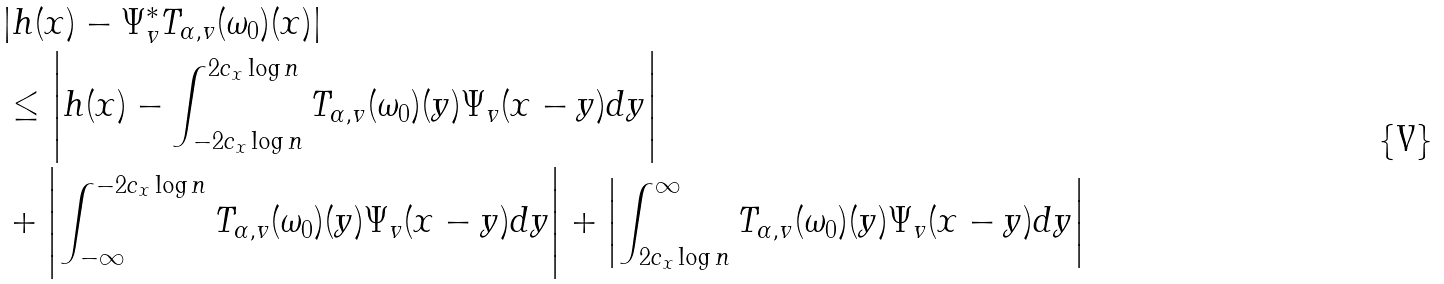<formula> <loc_0><loc_0><loc_500><loc_500>& | h ( x ) - \Psi _ { v } ^ { * } T _ { \alpha , v } ( \omega _ { 0 } ) ( x ) | \\ & \leq \left | h ( x ) - \int _ { - 2 c _ { x } \log n } ^ { 2 c _ { x } \log n } T _ { \alpha , v } ( \omega _ { 0 } ) ( y ) \Psi _ { v } ( x - y ) d y \right | \\ & + \left | \int _ { - \infty } ^ { - 2 c _ { x } \log n } T _ { \alpha , v } ( \omega _ { 0 } ) ( y ) \Psi _ { v } ( x - y ) d y \right | + \left | \int _ { 2 c _ { x } \log n } ^ { \infty } T _ { \alpha , v } ( \omega _ { 0 } ) ( y ) \Psi _ { v } ( x - y ) d y \right |</formula> 